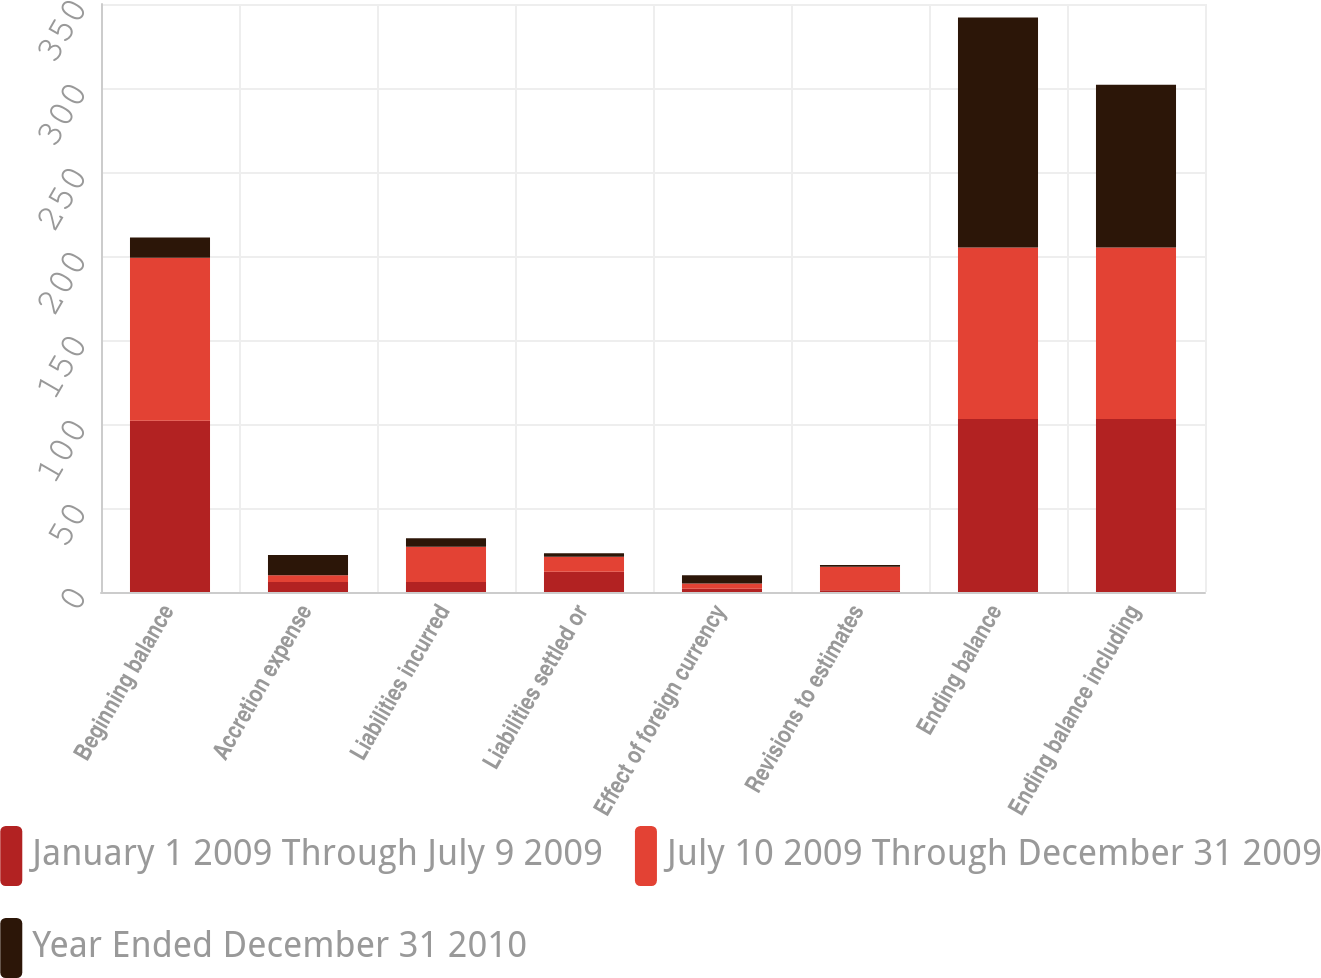Convert chart to OTSL. <chart><loc_0><loc_0><loc_500><loc_500><stacked_bar_chart><ecel><fcel>Beginning balance<fcel>Accretion expense<fcel>Liabilities incurred<fcel>Liabilities settled or<fcel>Effect of foreign currency<fcel>Revisions to estimates<fcel>Ending balance<fcel>Ending balance including<nl><fcel>January 1 2009 Through July 9 2009<fcel>102<fcel>6<fcel>6<fcel>12<fcel>2<fcel>1<fcel>103<fcel>103<nl><fcel>July 10 2009 Through December 31 2009<fcel>97<fcel>4<fcel>21<fcel>9<fcel>3<fcel>14<fcel>102<fcel>102<nl><fcel>Year Ended December 31 2010<fcel>12<fcel>12<fcel>5<fcel>2<fcel>5<fcel>1<fcel>137<fcel>97<nl></chart> 